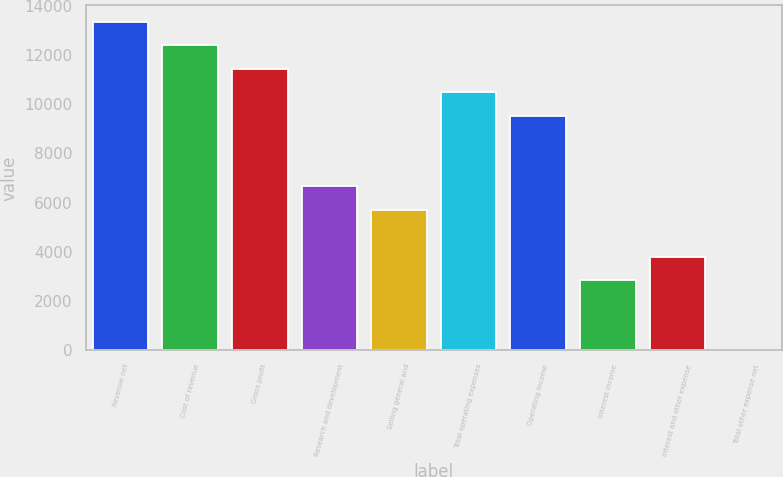<chart> <loc_0><loc_0><loc_500><loc_500><bar_chart><fcel>Revenue net<fcel>Cost of revenue<fcel>Gross profit<fcel>Research and development<fcel>Selling general and<fcel>Total operating expenses<fcel>Operating income<fcel>Interest income<fcel>Interest and other expense<fcel>Total other expense net<nl><fcel>13336<fcel>12383.5<fcel>11431<fcel>6668.5<fcel>5716<fcel>10478.5<fcel>9526<fcel>2858.5<fcel>3811<fcel>1<nl></chart> 